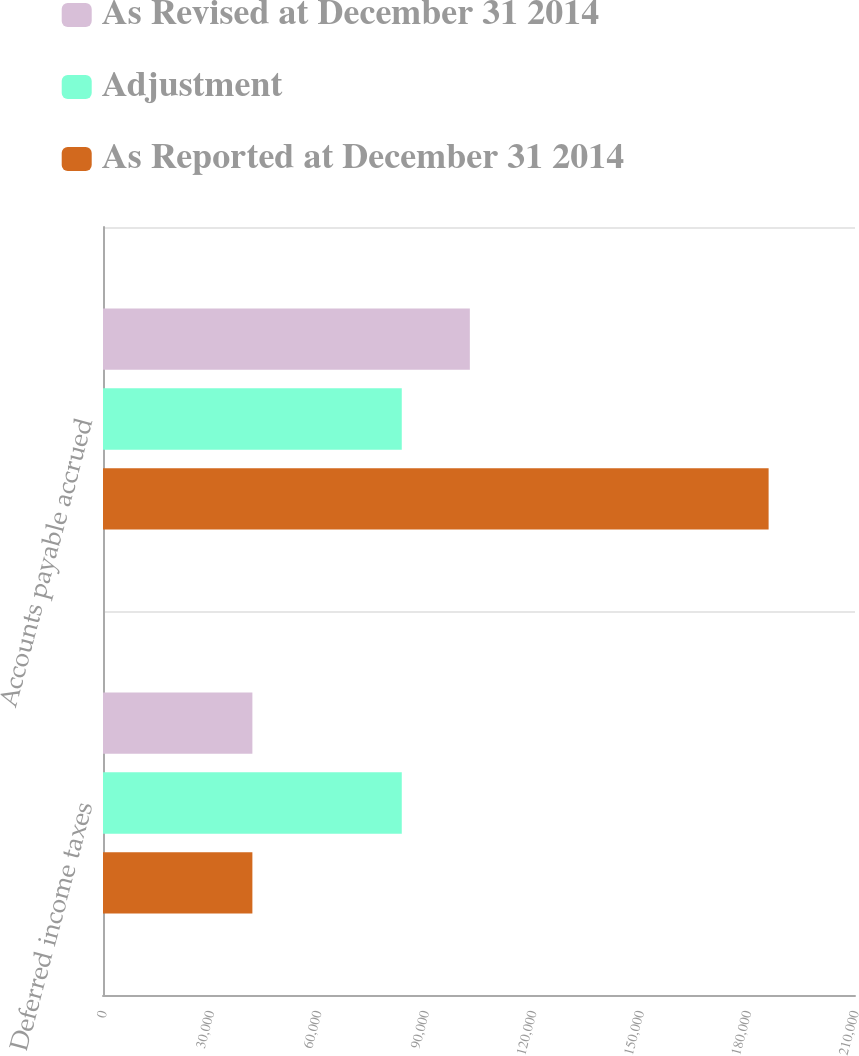<chart> <loc_0><loc_0><loc_500><loc_500><stacked_bar_chart><ecel><fcel>Deferred income taxes<fcel>Accounts payable accrued<nl><fcel>As Revised at December 31 2014<fcel>41716<fcel>102443<nl><fcel>Adjustment<fcel>83432<fcel>83432<nl><fcel>As Reported at December 31 2014<fcel>41716<fcel>185875<nl></chart> 